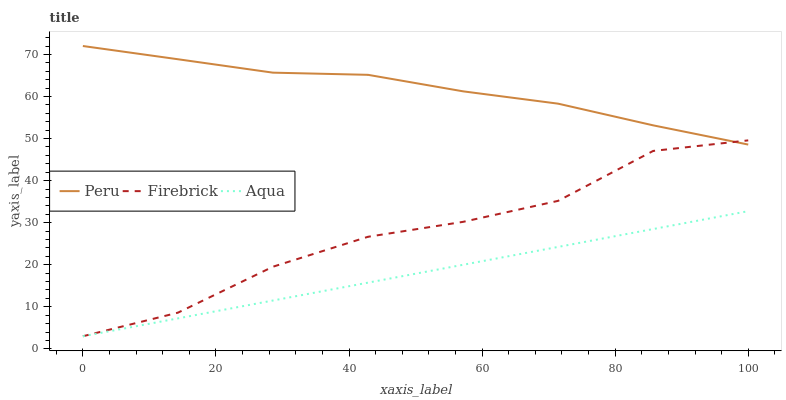Does Aqua have the minimum area under the curve?
Answer yes or no. Yes. Does Peru have the maximum area under the curve?
Answer yes or no. Yes. Does Peru have the minimum area under the curve?
Answer yes or no. No. Does Aqua have the maximum area under the curve?
Answer yes or no. No. Is Aqua the smoothest?
Answer yes or no. Yes. Is Firebrick the roughest?
Answer yes or no. Yes. Is Peru the smoothest?
Answer yes or no. No. Is Peru the roughest?
Answer yes or no. No. Does Firebrick have the lowest value?
Answer yes or no. Yes. Does Peru have the lowest value?
Answer yes or no. No. Does Peru have the highest value?
Answer yes or no. Yes. Does Aqua have the highest value?
Answer yes or no. No. Is Aqua less than Peru?
Answer yes or no. Yes. Is Peru greater than Aqua?
Answer yes or no. Yes. Does Firebrick intersect Peru?
Answer yes or no. Yes. Is Firebrick less than Peru?
Answer yes or no. No. Is Firebrick greater than Peru?
Answer yes or no. No. Does Aqua intersect Peru?
Answer yes or no. No. 